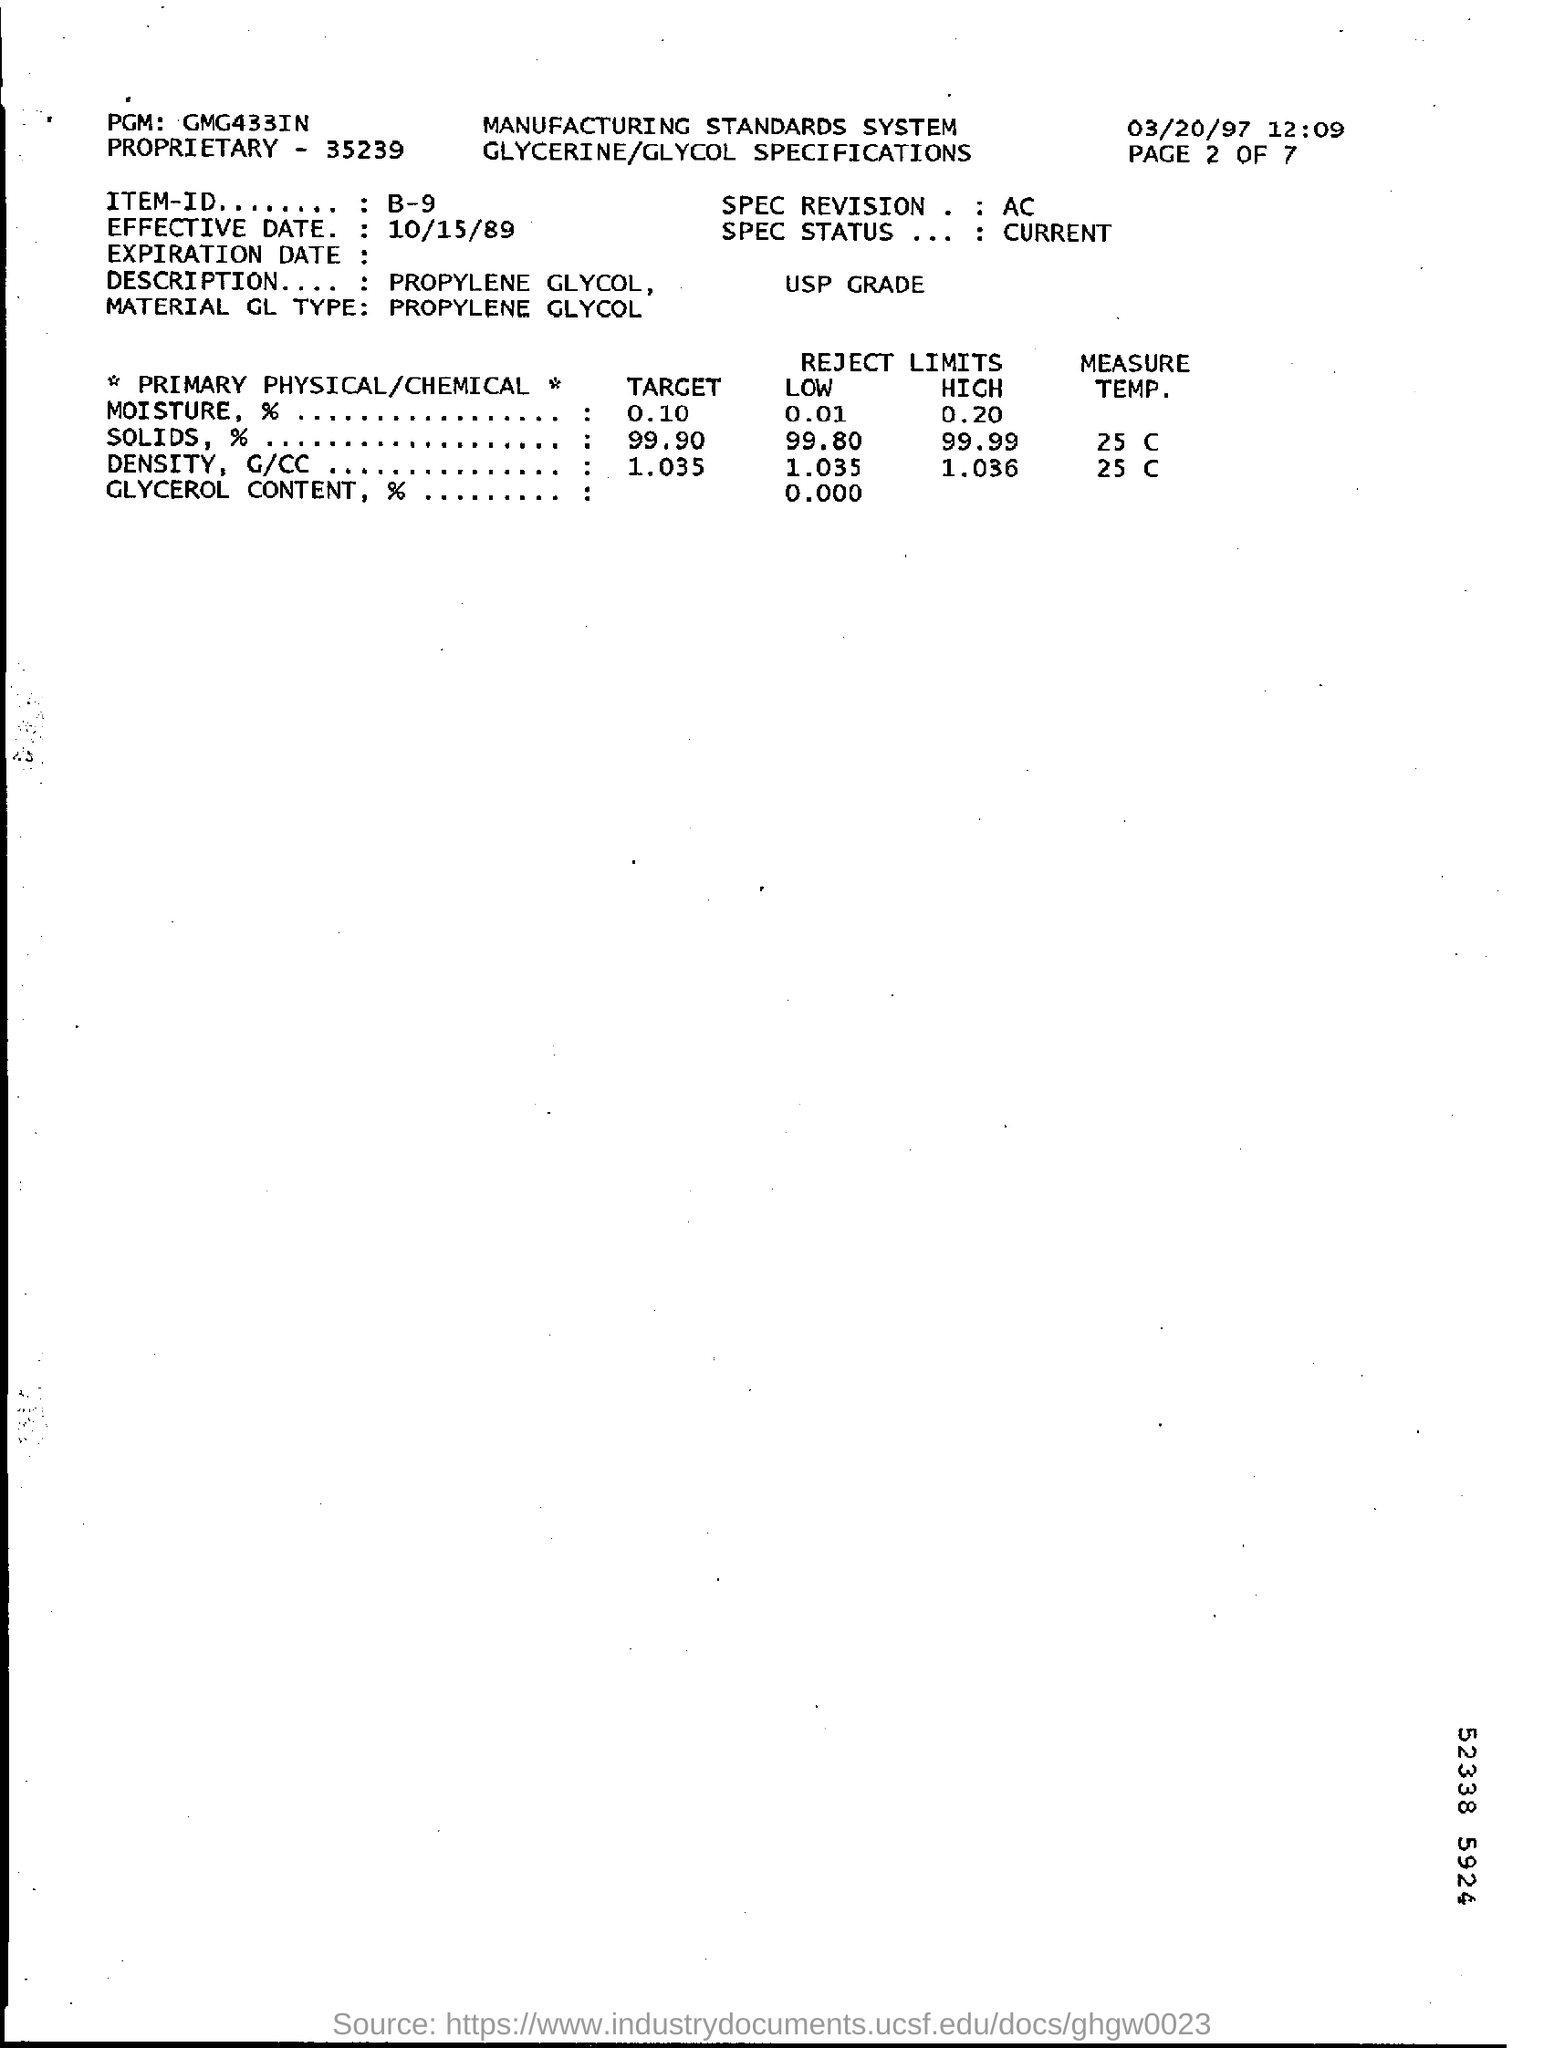Outline some significant characteristics in this image. The proprietary field contains the number 35239. The item-id field contains the written information B-9. The PGM Field contains the written text 'GMG433IN..'. The date on the top right of the document is March 20, 1997. The effective date of October 15, 1989, has been specified. 